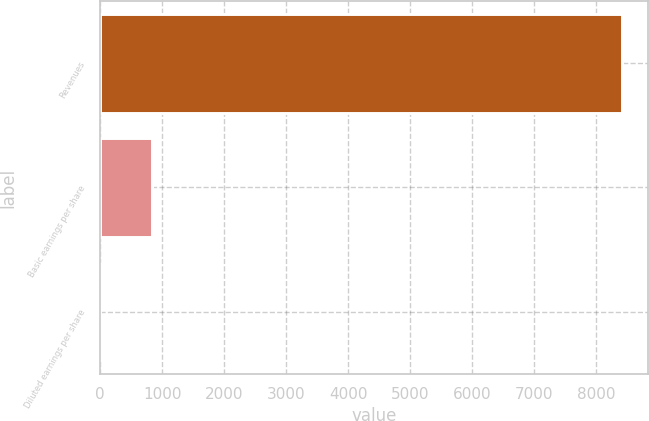<chart> <loc_0><loc_0><loc_500><loc_500><bar_chart><fcel>Revenues<fcel>Basic earnings per share<fcel>Diluted earnings per share<nl><fcel>8405<fcel>841.56<fcel>1.18<nl></chart> 